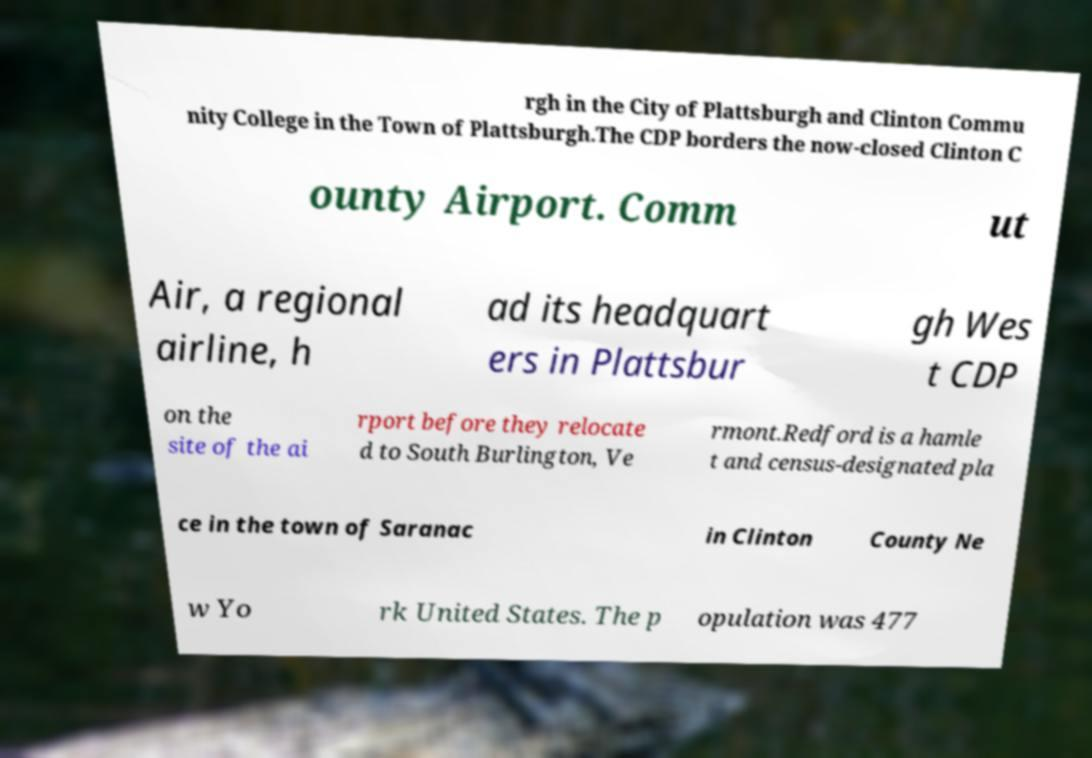Could you extract and type out the text from this image? rgh in the City of Plattsburgh and Clinton Commu nity College in the Town of Plattsburgh.The CDP borders the now-closed Clinton C ounty Airport. Comm ut Air, a regional airline, h ad its headquart ers in Plattsbur gh Wes t CDP on the site of the ai rport before they relocate d to South Burlington, Ve rmont.Redford is a hamle t and census-designated pla ce in the town of Saranac in Clinton County Ne w Yo rk United States. The p opulation was 477 